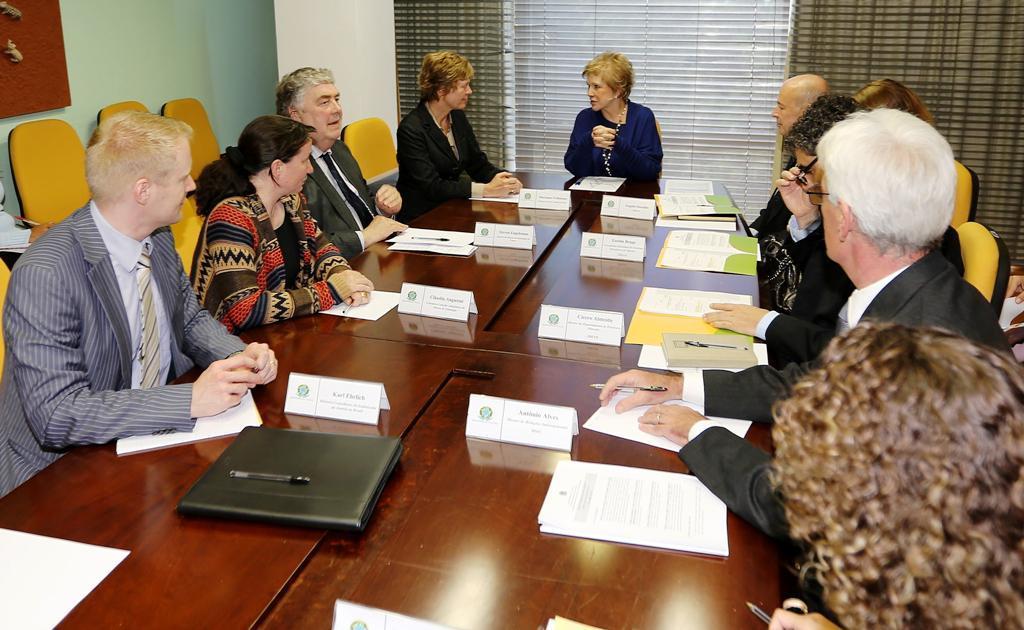Can you describe this image briefly? In this picture we can observe some people sitting in the yellow color chairs around this brown color table. We can observe name boards, papers and pens on this table. There are men and women in this picture. In the background we can observe a curtain which is in brown color. On the left side we can observe green color wall. 